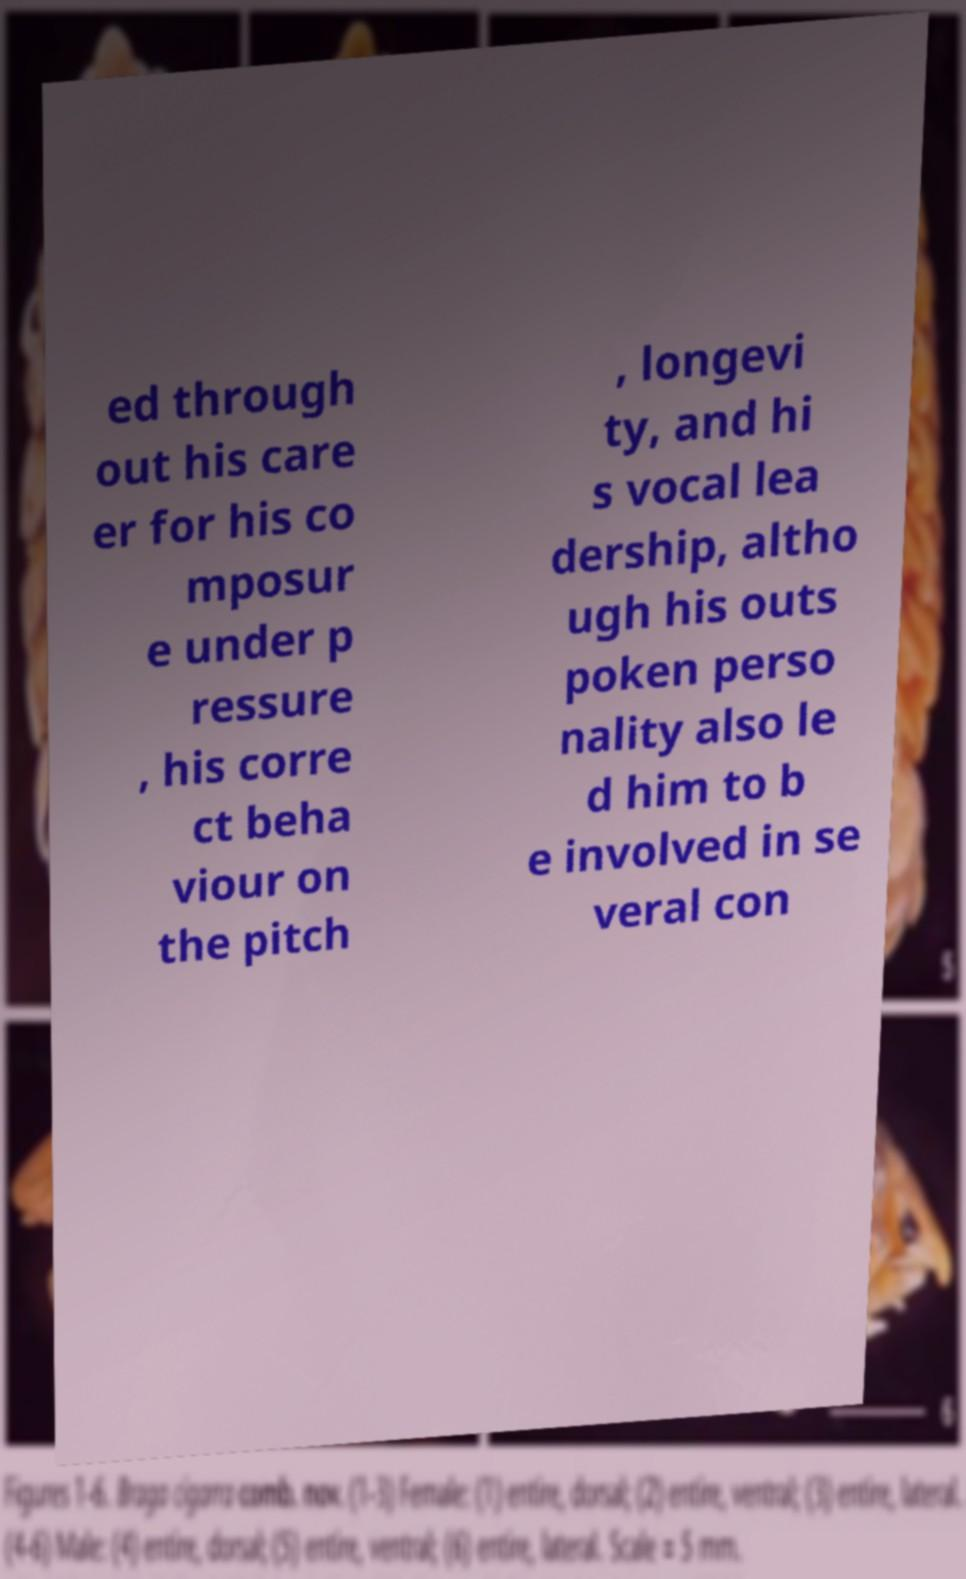Could you extract and type out the text from this image? ed through out his care er for his co mposur e under p ressure , his corre ct beha viour on the pitch , longevi ty, and hi s vocal lea dership, altho ugh his outs poken perso nality also le d him to b e involved in se veral con 